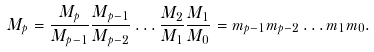Convert formula to latex. <formula><loc_0><loc_0><loc_500><loc_500>M _ { p } = \frac { M _ { p } } { M _ { p - 1 } } \frac { M _ { p - 1 } } { M _ { p - 2 } } \dots \frac { M _ { 2 } } { M _ { 1 } } \frac { M _ { 1 } } { M _ { 0 } } = m _ { p - 1 } m _ { p - 2 } \dots m _ { 1 } m _ { 0 } .</formula> 